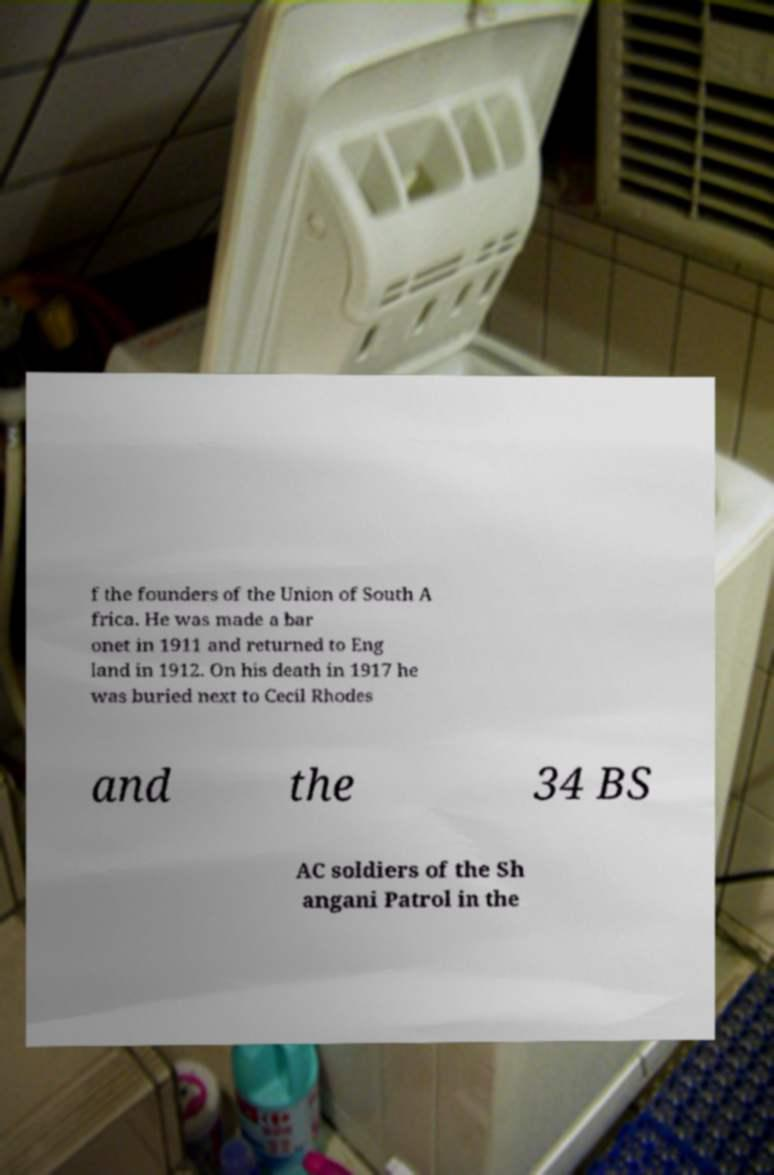Can you read and provide the text displayed in the image?This photo seems to have some interesting text. Can you extract and type it out for me? f the founders of the Union of South A frica. He was made a bar onet in 1911 and returned to Eng land in 1912. On his death in 1917 he was buried next to Cecil Rhodes and the 34 BS AC soldiers of the Sh angani Patrol in the 